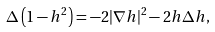Convert formula to latex. <formula><loc_0><loc_0><loc_500><loc_500>\Delta \left ( 1 - h ^ { 2 } \right ) = - 2 | \nabla h | ^ { 2 } - 2 h \Delta h ,</formula> 